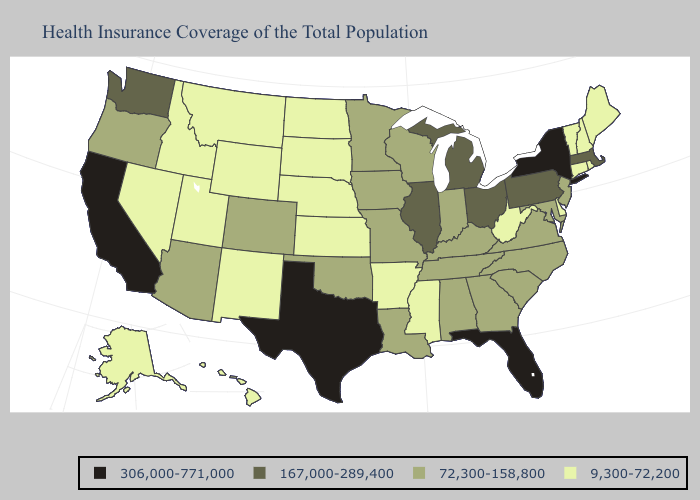What is the lowest value in states that border New Jersey?
Answer briefly. 9,300-72,200. Does the map have missing data?
Write a very short answer. No. Does Illinois have the lowest value in the USA?
Concise answer only. No. Name the states that have a value in the range 167,000-289,400?
Short answer required. Illinois, Massachusetts, Michigan, Ohio, Pennsylvania, Washington. What is the lowest value in the MidWest?
Be succinct. 9,300-72,200. Name the states that have a value in the range 72,300-158,800?
Answer briefly. Alabama, Arizona, Colorado, Georgia, Indiana, Iowa, Kentucky, Louisiana, Maryland, Minnesota, Missouri, New Jersey, North Carolina, Oklahoma, Oregon, South Carolina, Tennessee, Virginia, Wisconsin. Name the states that have a value in the range 306,000-771,000?
Quick response, please. California, Florida, New York, Texas. What is the lowest value in states that border New Jersey?
Give a very brief answer. 9,300-72,200. What is the value of Minnesota?
Give a very brief answer. 72,300-158,800. Among the states that border Maryland , which have the lowest value?
Write a very short answer. Delaware, West Virginia. Does Oklahoma have the same value as Kentucky?
Be succinct. Yes. What is the value of South Carolina?
Give a very brief answer. 72,300-158,800. Does Florida have the highest value in the USA?
Keep it brief. Yes. Name the states that have a value in the range 167,000-289,400?
Give a very brief answer. Illinois, Massachusetts, Michigan, Ohio, Pennsylvania, Washington. Is the legend a continuous bar?
Be succinct. No. 